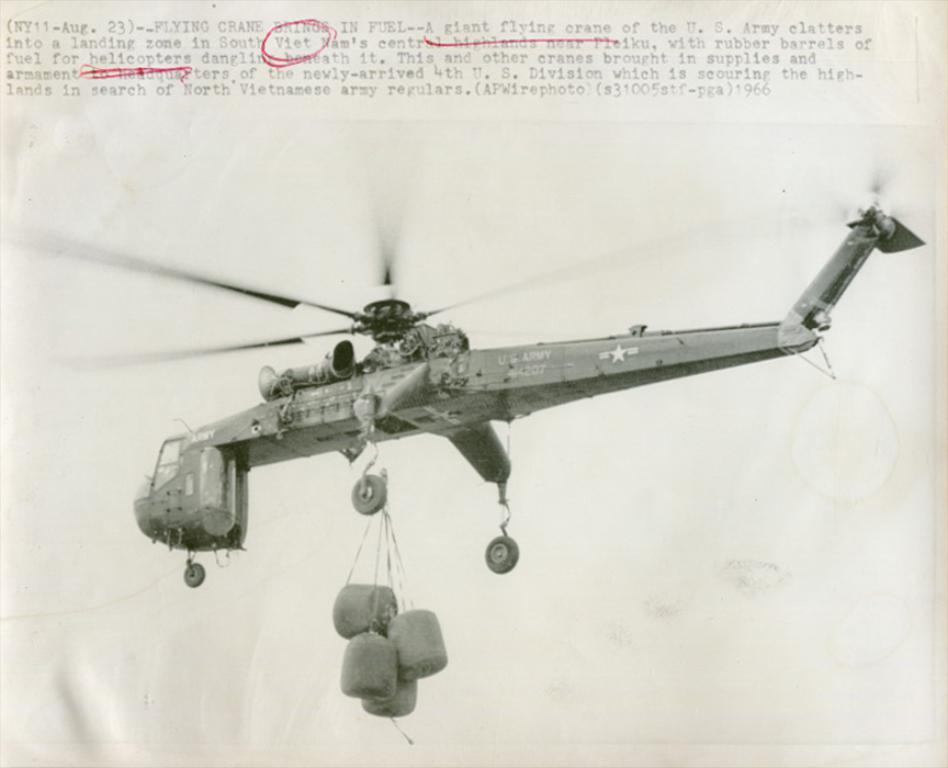What is the main subject of the image? The main subject of the image is a picture of a flight. What can be seen hanging under the flight? There are objects hanging under the flight. What part of the flight is visible in the image? The wheel of the flight is visible. What is written or depicted at the top of the image? There is text at the top of the image. What type of crate is being used to store the locket during the holiday in the image? There is no crate, locket, or holiday depicted in the image; it features a picture of a flight with objects hanging under it and text at the top. 